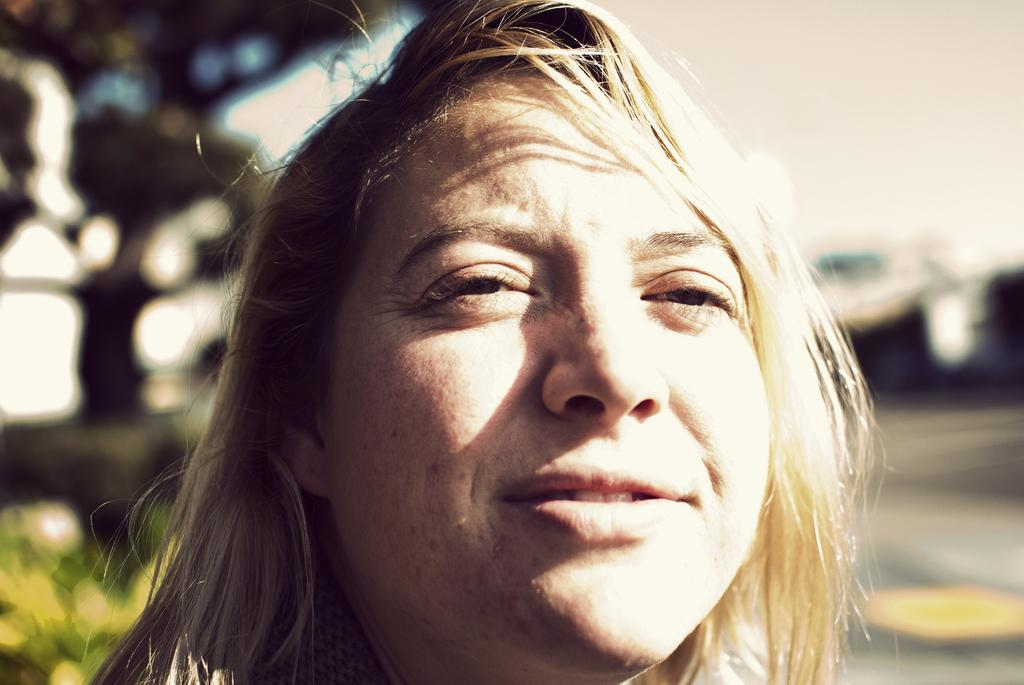What is the main subject of the image? There is a woman's face in the image. Can you describe the background of the image? The background of the image is blurry. What type of quill is the woman holding in the image? There is no quill present in the image; it only features a woman's face with a blurry background. How many fruits can be seen in the image? There are no fruits present in the image. 